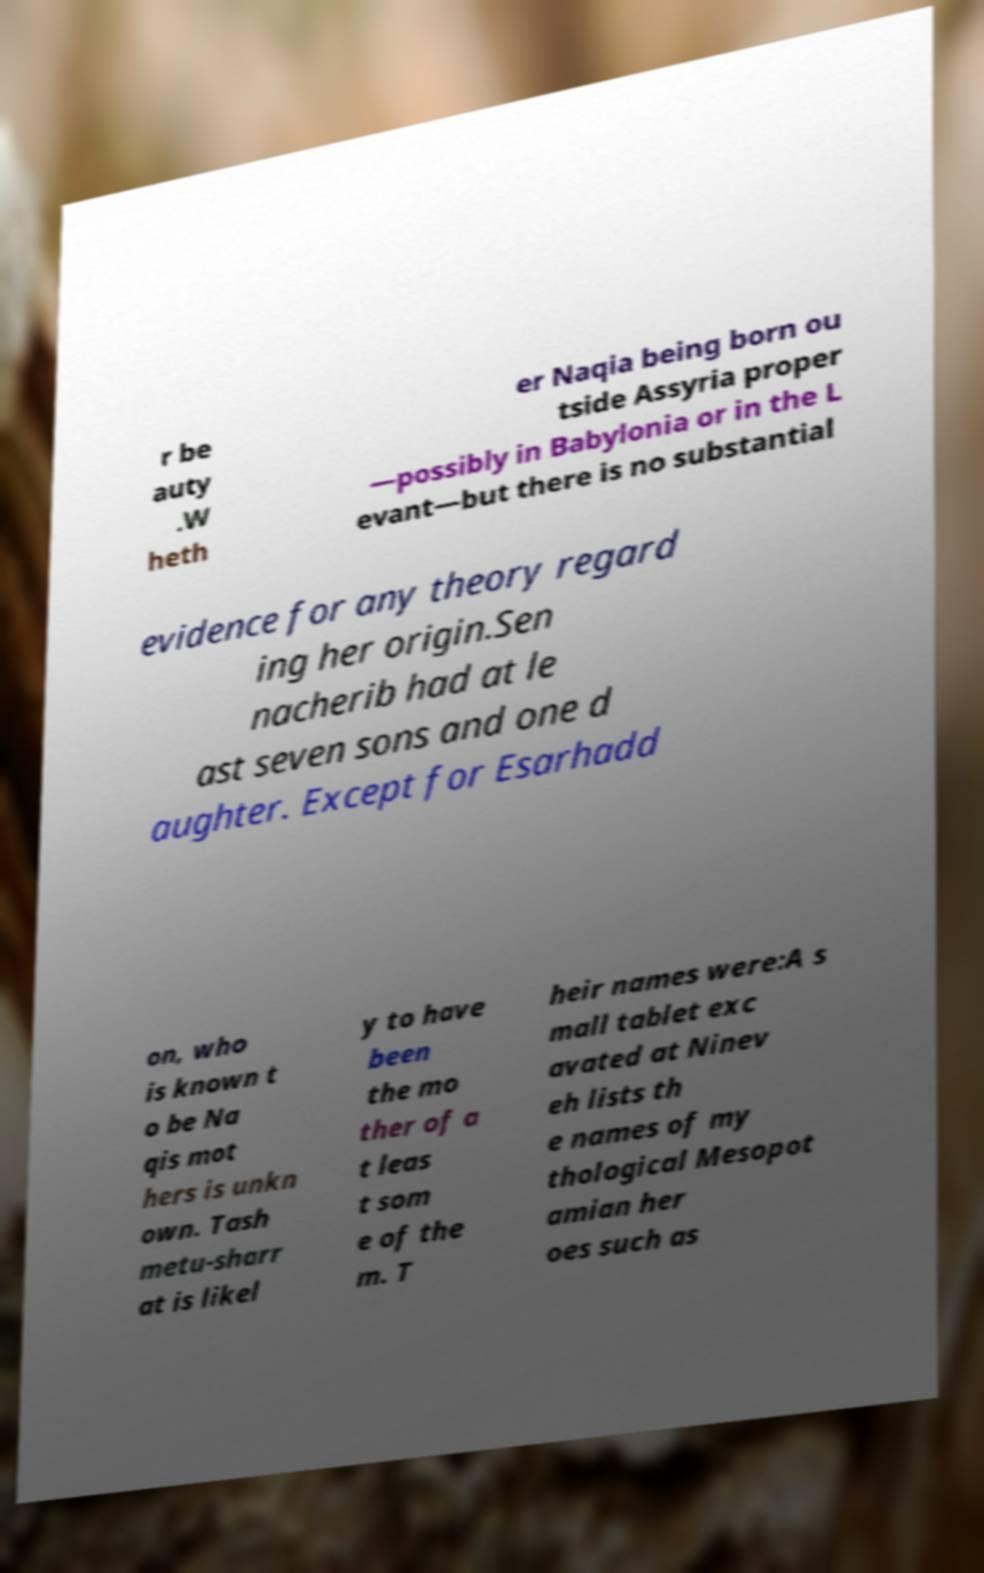What messages or text are displayed in this image? I need them in a readable, typed format. r be auty .W heth er Naqia being born ou tside Assyria proper —possibly in Babylonia or in the L evant—but there is no substantial evidence for any theory regard ing her origin.Sen nacherib had at le ast seven sons and one d aughter. Except for Esarhadd on, who is known t o be Na qis mot hers is unkn own. Tash metu-sharr at is likel y to have been the mo ther of a t leas t som e of the m. T heir names were:A s mall tablet exc avated at Ninev eh lists th e names of my thological Mesopot amian her oes such as 